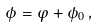<formula> <loc_0><loc_0><loc_500><loc_500>\phi = \varphi + \phi _ { 0 } \, ,</formula> 